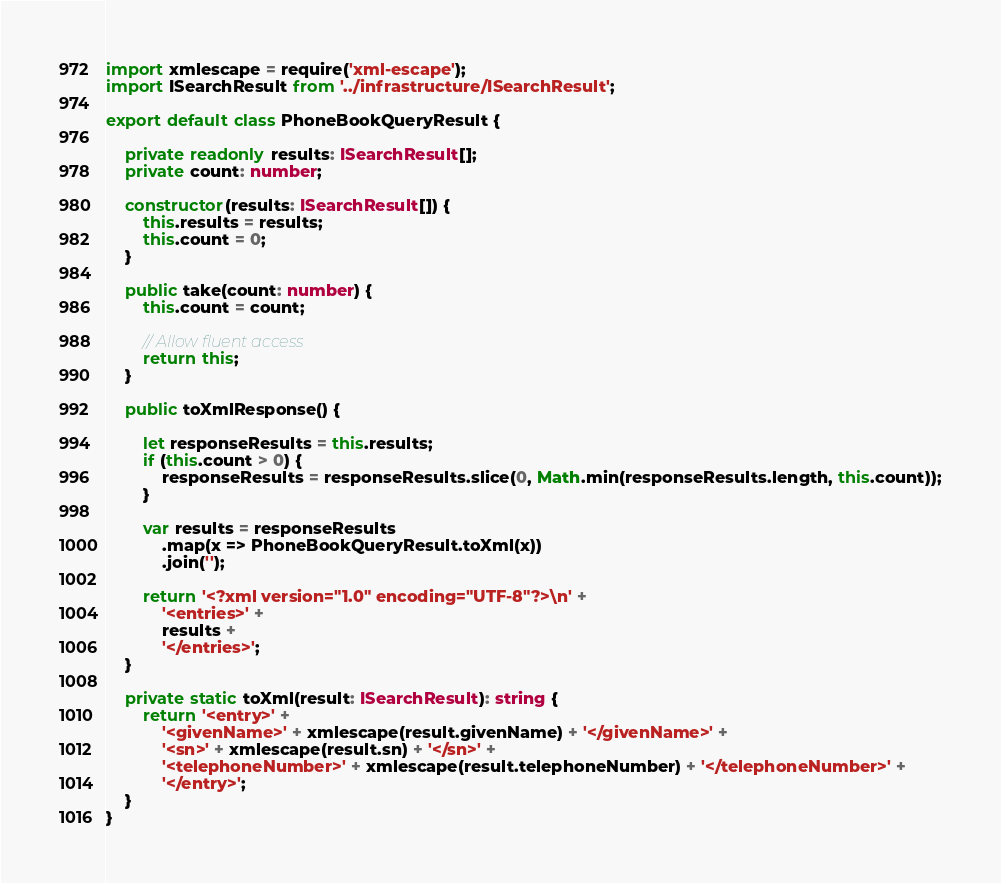<code> <loc_0><loc_0><loc_500><loc_500><_TypeScript_>import xmlescape = require('xml-escape');
import ISearchResult from '../infrastructure/ISearchResult';

export default class PhoneBookQueryResult {

    private readonly results: ISearchResult[];
    private count: number;

    constructor(results: ISearchResult[]) {
        this.results = results;
        this.count = 0;
    }

    public take(count: number) {
        this.count = count;

        // Allow fluent access
        return this;
    }

    public toXmlResponse() {

        let responseResults = this.results;
        if (this.count > 0) {
            responseResults = responseResults.slice(0, Math.min(responseResults.length, this.count));
        }

        var results = responseResults
            .map(x => PhoneBookQueryResult.toXml(x))
            .join('');

        return '<?xml version="1.0" encoding="UTF-8"?>\n' +
            '<entries>' +
            results +
            '</entries>';
    }

    private static toXml(result: ISearchResult): string {
        return '<entry>' +
            '<givenName>' + xmlescape(result.givenName) + '</givenName>' +
            '<sn>' + xmlescape(result.sn) + '</sn>' +
            '<telephoneNumber>' + xmlescape(result.telephoneNumber) + '</telephoneNumber>' +
            '</entry>';
    }
}</code> 